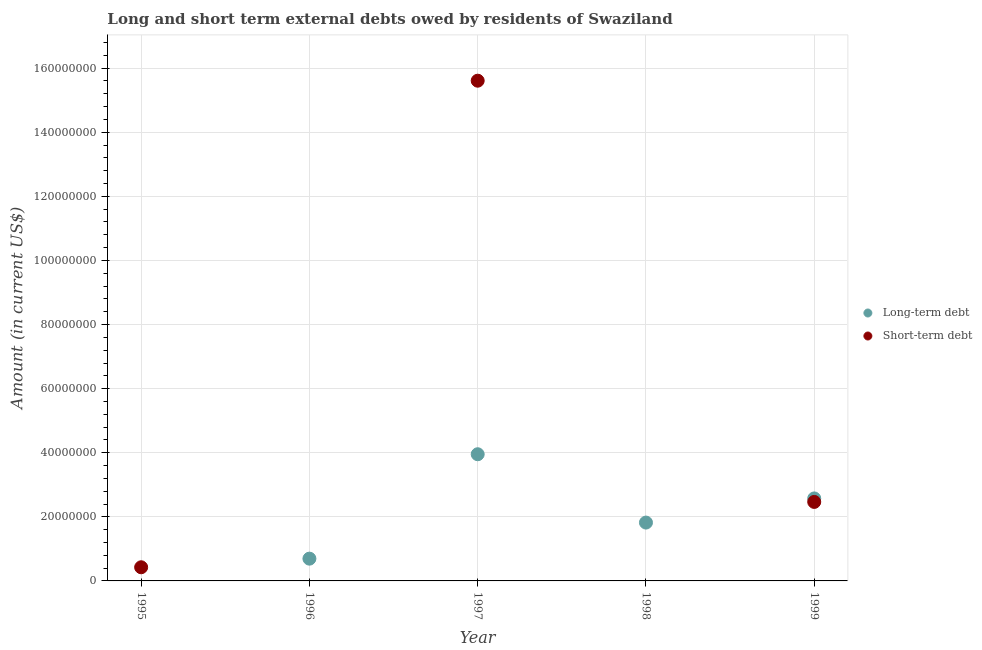What is the long-term debts owed by residents in 1998?
Make the answer very short. 1.82e+07. Across all years, what is the maximum short-term debts owed by residents?
Ensure brevity in your answer.  1.56e+08. What is the total short-term debts owed by residents in the graph?
Ensure brevity in your answer.  1.85e+08. What is the difference between the long-term debts owed by residents in 1997 and that in 1999?
Offer a very short reply. 1.38e+07. What is the difference between the short-term debts owed by residents in 1997 and the long-term debts owed by residents in 1996?
Make the answer very short. 1.49e+08. What is the average long-term debts owed by residents per year?
Ensure brevity in your answer.  1.81e+07. In the year 1997, what is the difference between the long-term debts owed by residents and short-term debts owed by residents?
Provide a succinct answer. -1.17e+08. What is the ratio of the short-term debts owed by residents in 1995 to that in 1999?
Keep it short and to the point. 0.17. What is the difference between the highest and the second highest long-term debts owed by residents?
Your answer should be very brief. 1.38e+07. What is the difference between the highest and the lowest long-term debts owed by residents?
Your answer should be very brief. 3.95e+07. In how many years, is the short-term debts owed by residents greater than the average short-term debts owed by residents taken over all years?
Your answer should be very brief. 1. Is the long-term debts owed by residents strictly greater than the short-term debts owed by residents over the years?
Give a very brief answer. No. How many dotlines are there?
Your answer should be compact. 2. How many years are there in the graph?
Your answer should be very brief. 5. Does the graph contain any zero values?
Make the answer very short. Yes. Does the graph contain grids?
Keep it short and to the point. Yes. What is the title of the graph?
Offer a terse response. Long and short term external debts owed by residents of Swaziland. What is the Amount (in current US$) in Long-term debt in 1995?
Make the answer very short. 0. What is the Amount (in current US$) in Short-term debt in 1995?
Offer a very short reply. 4.26e+06. What is the Amount (in current US$) in Long-term debt in 1996?
Your response must be concise. 6.95e+06. What is the Amount (in current US$) in Long-term debt in 1997?
Keep it short and to the point. 3.95e+07. What is the Amount (in current US$) of Short-term debt in 1997?
Keep it short and to the point. 1.56e+08. What is the Amount (in current US$) in Long-term debt in 1998?
Keep it short and to the point. 1.82e+07. What is the Amount (in current US$) of Short-term debt in 1998?
Keep it short and to the point. 0. What is the Amount (in current US$) of Long-term debt in 1999?
Keep it short and to the point. 2.57e+07. What is the Amount (in current US$) in Short-term debt in 1999?
Your answer should be compact. 2.46e+07. Across all years, what is the maximum Amount (in current US$) in Long-term debt?
Give a very brief answer. 3.95e+07. Across all years, what is the maximum Amount (in current US$) of Short-term debt?
Your answer should be very brief. 1.56e+08. What is the total Amount (in current US$) in Long-term debt in the graph?
Your answer should be compact. 9.04e+07. What is the total Amount (in current US$) of Short-term debt in the graph?
Ensure brevity in your answer.  1.85e+08. What is the difference between the Amount (in current US$) in Short-term debt in 1995 and that in 1997?
Make the answer very short. -1.52e+08. What is the difference between the Amount (in current US$) in Short-term debt in 1995 and that in 1999?
Provide a short and direct response. -2.04e+07. What is the difference between the Amount (in current US$) of Long-term debt in 1996 and that in 1997?
Offer a terse response. -3.26e+07. What is the difference between the Amount (in current US$) of Long-term debt in 1996 and that in 1998?
Your response must be concise. -1.13e+07. What is the difference between the Amount (in current US$) of Long-term debt in 1996 and that in 1999?
Give a very brief answer. -1.88e+07. What is the difference between the Amount (in current US$) of Long-term debt in 1997 and that in 1998?
Give a very brief answer. 2.13e+07. What is the difference between the Amount (in current US$) in Long-term debt in 1997 and that in 1999?
Offer a very short reply. 1.38e+07. What is the difference between the Amount (in current US$) of Short-term debt in 1997 and that in 1999?
Keep it short and to the point. 1.31e+08. What is the difference between the Amount (in current US$) in Long-term debt in 1998 and that in 1999?
Provide a short and direct response. -7.54e+06. What is the difference between the Amount (in current US$) of Long-term debt in 1996 and the Amount (in current US$) of Short-term debt in 1997?
Offer a terse response. -1.49e+08. What is the difference between the Amount (in current US$) of Long-term debt in 1996 and the Amount (in current US$) of Short-term debt in 1999?
Give a very brief answer. -1.77e+07. What is the difference between the Amount (in current US$) in Long-term debt in 1997 and the Amount (in current US$) in Short-term debt in 1999?
Your answer should be very brief. 1.49e+07. What is the difference between the Amount (in current US$) in Long-term debt in 1998 and the Amount (in current US$) in Short-term debt in 1999?
Your answer should be very brief. -6.44e+06. What is the average Amount (in current US$) of Long-term debt per year?
Your answer should be compact. 1.81e+07. What is the average Amount (in current US$) of Short-term debt per year?
Provide a short and direct response. 3.70e+07. In the year 1997, what is the difference between the Amount (in current US$) of Long-term debt and Amount (in current US$) of Short-term debt?
Give a very brief answer. -1.17e+08. In the year 1999, what is the difference between the Amount (in current US$) in Long-term debt and Amount (in current US$) in Short-term debt?
Your answer should be very brief. 1.09e+06. What is the ratio of the Amount (in current US$) in Short-term debt in 1995 to that in 1997?
Your answer should be compact. 0.03. What is the ratio of the Amount (in current US$) in Short-term debt in 1995 to that in 1999?
Provide a short and direct response. 0.17. What is the ratio of the Amount (in current US$) in Long-term debt in 1996 to that in 1997?
Give a very brief answer. 0.18. What is the ratio of the Amount (in current US$) of Long-term debt in 1996 to that in 1998?
Ensure brevity in your answer.  0.38. What is the ratio of the Amount (in current US$) in Long-term debt in 1996 to that in 1999?
Keep it short and to the point. 0.27. What is the ratio of the Amount (in current US$) of Long-term debt in 1997 to that in 1998?
Keep it short and to the point. 2.17. What is the ratio of the Amount (in current US$) of Long-term debt in 1997 to that in 1999?
Keep it short and to the point. 1.54. What is the ratio of the Amount (in current US$) in Short-term debt in 1997 to that in 1999?
Give a very brief answer. 6.33. What is the ratio of the Amount (in current US$) in Long-term debt in 1998 to that in 1999?
Offer a very short reply. 0.71. What is the difference between the highest and the second highest Amount (in current US$) in Long-term debt?
Keep it short and to the point. 1.38e+07. What is the difference between the highest and the second highest Amount (in current US$) in Short-term debt?
Offer a very short reply. 1.31e+08. What is the difference between the highest and the lowest Amount (in current US$) of Long-term debt?
Provide a short and direct response. 3.95e+07. What is the difference between the highest and the lowest Amount (in current US$) in Short-term debt?
Offer a very short reply. 1.56e+08. 